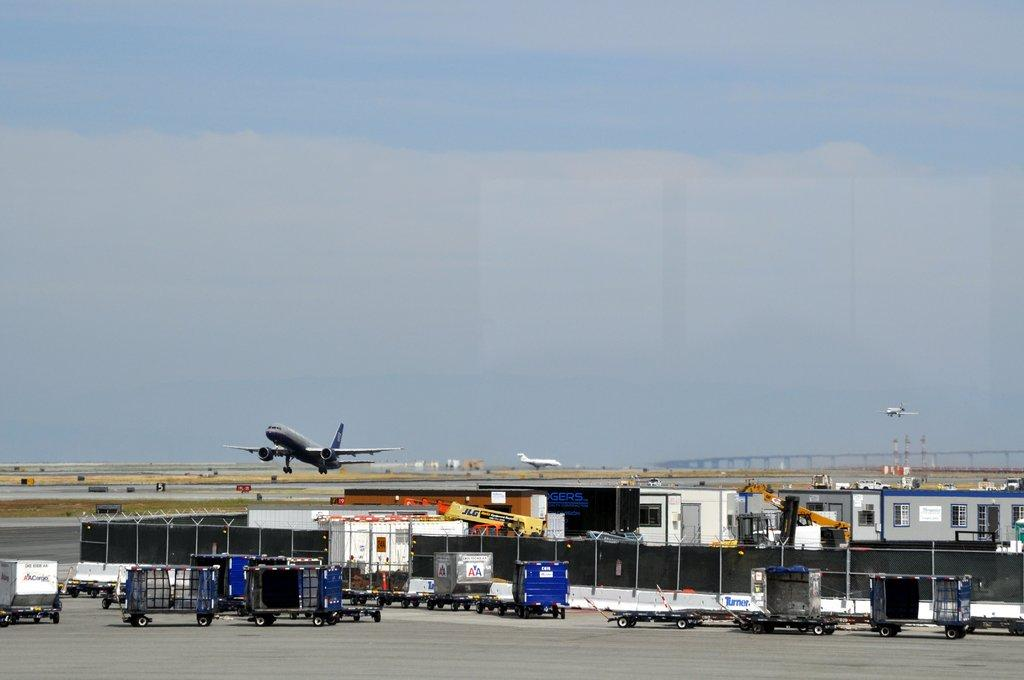What type of vehicles can be seen in the image? There are trucks in the image. What can be seen in the background of the image? There is a runway and aeroplanes visible in the background of the image. What other types of vehicles are present in the image? There are vehicles in the image. What type of bear can be seen regretting its decision to drive a car in the image? There is no bear or car present in the image, and therefore no such activity can be observed. 